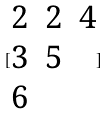<formula> <loc_0><loc_0><loc_500><loc_500>[ \begin{matrix} 2 & 2 & 4 \\ 3 & 5 \\ 6 \end{matrix} ]</formula> 